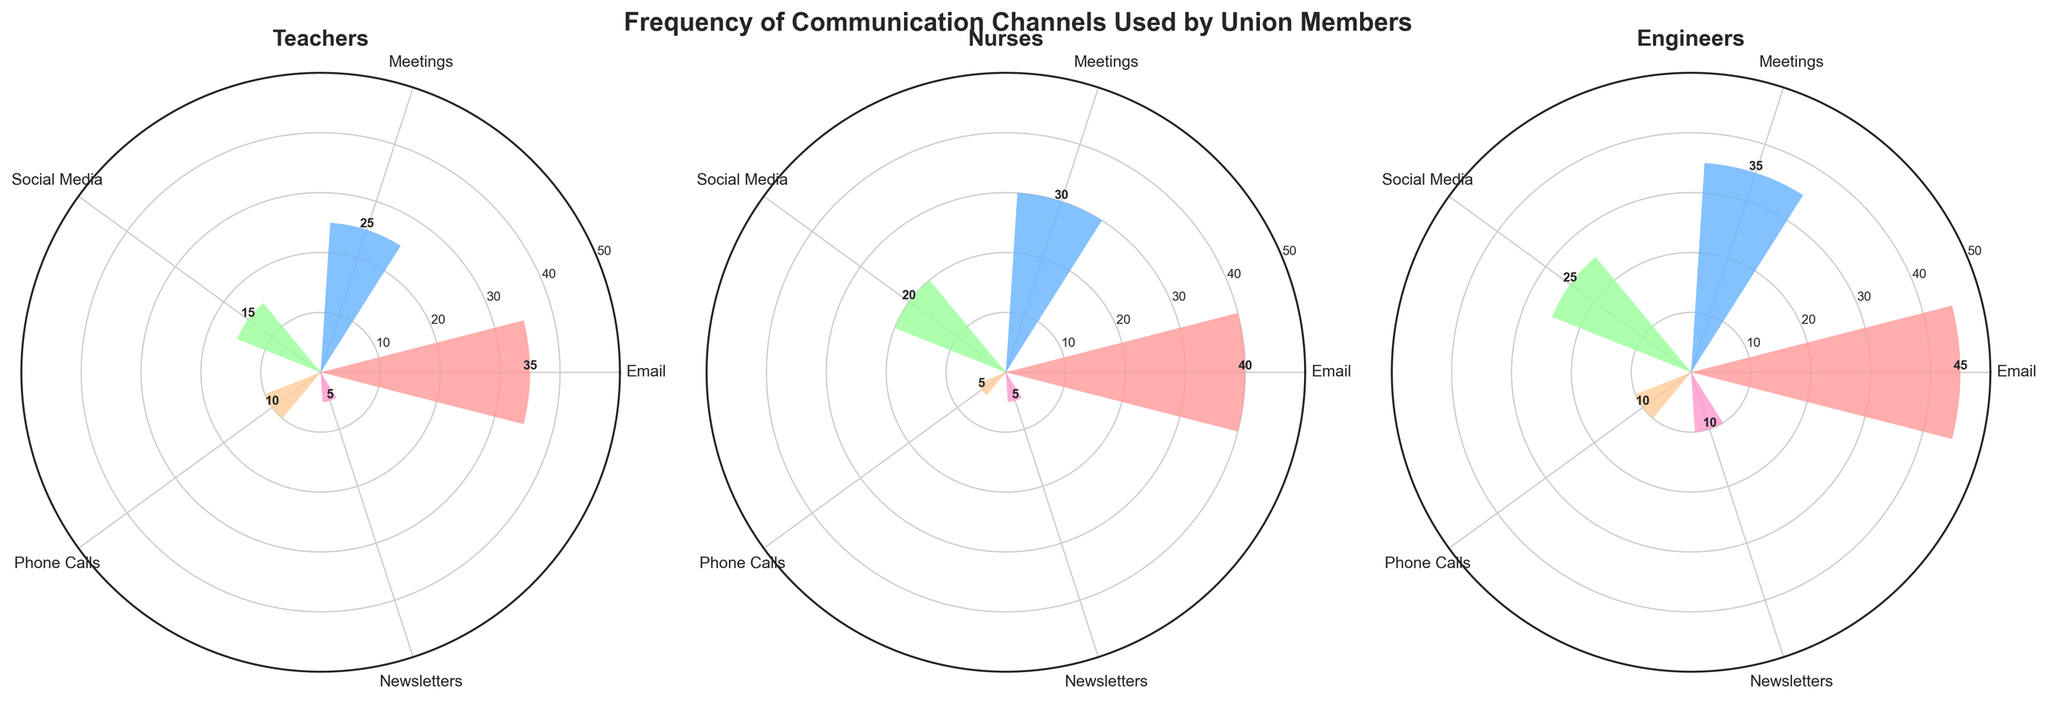what is the title of the chart? The title is prominently displayed at the top of the figure in a large, bold font. It reads: "Frequency of Communication Channels Used by Union Members."
Answer: Frequency of Communication Channels Used by Union Members How many member groups are represented in the figure? The figure contains three polar subplots, each labeled with a different member group, namely "Teachers," "Nurses," and "Engineers."
Answer: 3 Which communication channel is used the most by Engineers? By observing the polar subplot for Engineers, the bar with the highest value is for "Email," and the frequency for this channel is highest among others.
Answer: Email What is the overall trend in frequency usage of phone calls among all member groups? All three subplots show relatively low bars for the "Phone Calls" category, with Teachers and Engineers both having a frequency of 10, and Nurses having the lowest at 5.
Answer: Low usage Compare the frequency of Email usage between Teachers and Nurses. Which group uses it more? In the subplots, the frequency for "Email" is 35 for Teachers and 40 for Nurses. Therefore, Nurses use Email more than Teachers.
Answer: Nurses What is the average frequency of meetings across all member groups? The frequencies for "Meetings" are 25 (Teachers), 30 (Nurses), and 35 (Engineers). Summing these up gives 90, and dividing by the 3 groups gives an average frequency of 30.
Answer: 30 Which member group shows the least frequency for using newsletters? Looking at the subplots, both Teachers and Nurses show a frequency of 5 for newsletters while Engineers have a frequency of 10. Thus, Teachers and Nurses both show the least frequency.
Answer: Teachers and Nurses Identify the communication channel with the second-highest frequency for Nurses. In the Nurses' subplot, the bar heights show Email with the highest frequency at 40, and Meetings with the next highest frequency at 30. Thus, Meetings is the second-highest.
Answer: Meetings For which communication channel is there the most consistent use (same frequency across all member groups)? By checking all subplots, Newsletters' frequency is consistent: 5 for Teachers, 5 for Nurses, and 10 for Engineers. No channel has the exact same frequency for all groups, but Newsletters show the most consistent with two matching values.
Answer: Newsletters What is the total frequency of social media usage across all member groups combined? The frequencies for "Social Media" are 15 (Teachers), 20 (Nurses), and 25 (Engineers). Summing these gives a total frequency of 60.
Answer: 60 Which member group has the highest total frequency for all communication channels combined? The frequencies for each communication channel in each group need to be summed up:
- Teachers: 35 (Email) + 25 (Meetings) + 15 (Social Media) + 10 (Phone Calls) + 5 (Newsletters) = 90
- Nurses: 40 (Email) + 30 (Meetings) + 20 (Social Media) + 5 (Phone Calls) + 5 (Newsletters) = 100
- Engineers: 45 (Email) + 35 (Meetings) + 25 (Social Media) + 10 (Phone Calls) + 10 (Newsletters) = 125
Therefore, Engineers have the highest total frequency.
Answer: Engineers 